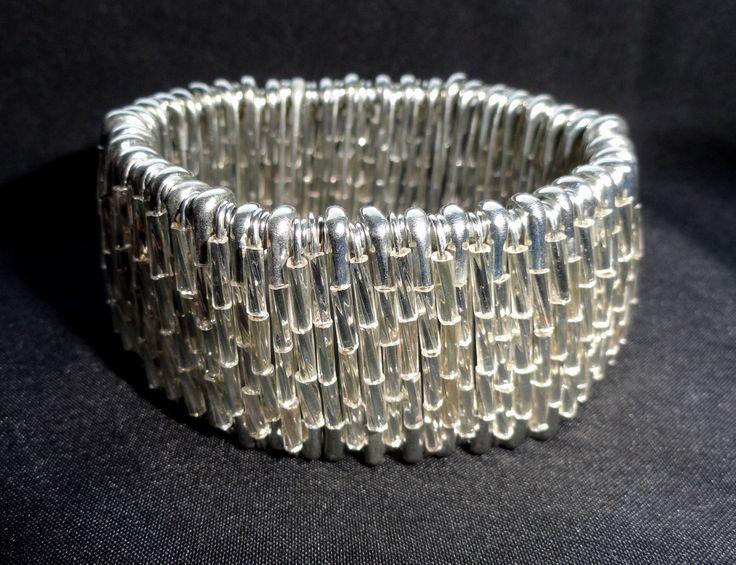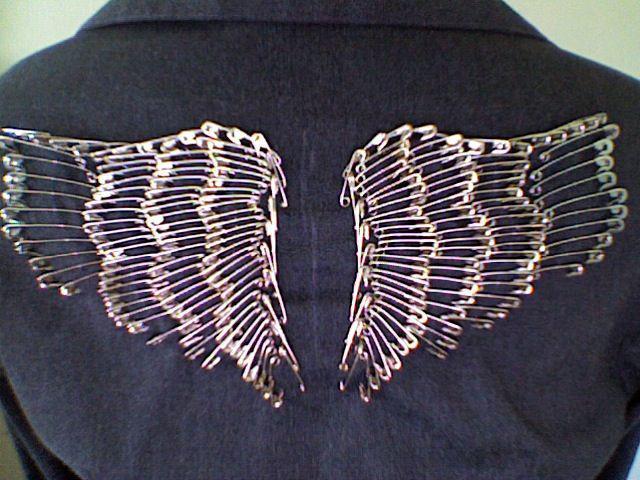The first image is the image on the left, the second image is the image on the right. Given the left and right images, does the statement "One of the images shows both the legs and arms of a model." hold true? Answer yes or no. No. 